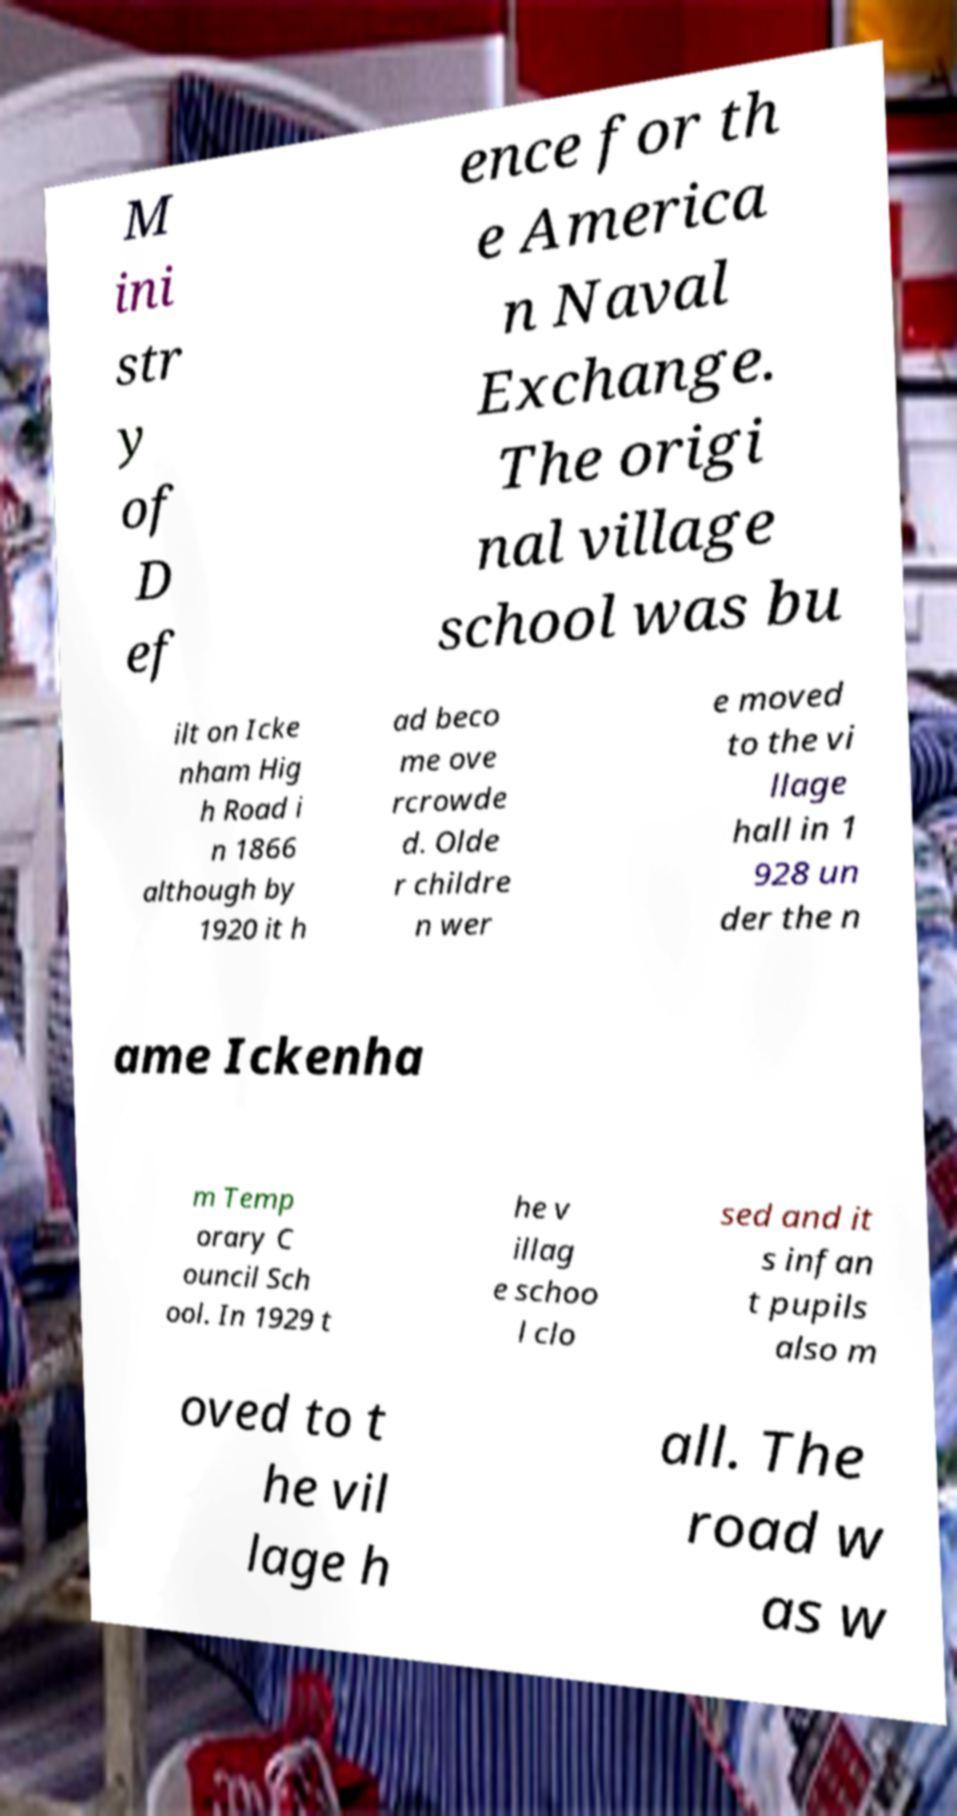Could you assist in decoding the text presented in this image and type it out clearly? M ini str y of D ef ence for th e America n Naval Exchange. The origi nal village school was bu ilt on Icke nham Hig h Road i n 1866 although by 1920 it h ad beco me ove rcrowde d. Olde r childre n wer e moved to the vi llage hall in 1 928 un der the n ame Ickenha m Temp orary C ouncil Sch ool. In 1929 t he v illag e schoo l clo sed and it s infan t pupils also m oved to t he vil lage h all. The road w as w 